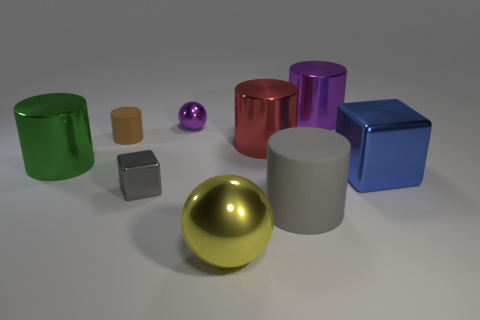There is a ball that is behind the big blue shiny object; how big is it?
Give a very brief answer. Small. How many green things are large rubber things or shiny spheres?
Provide a succinct answer. 0. Is there a yellow metallic ball that has the same size as the red metallic cylinder?
Ensure brevity in your answer.  Yes. There is a gray block that is the same size as the brown matte object; what is it made of?
Make the answer very short. Metal. Is the size of the shiny cylinder that is to the left of the brown matte thing the same as the shiny sphere in front of the green object?
Your answer should be compact. Yes. How many things are either tiny gray metal balls or objects that are to the left of the large purple shiny cylinder?
Offer a very short reply. 7. Are there any big red metal objects that have the same shape as the yellow object?
Provide a succinct answer. No. What size is the metallic cube that is right of the large cylinder in front of the tiny gray shiny thing?
Provide a succinct answer. Large. Is the large shiny sphere the same color as the tiny cylinder?
Make the answer very short. No. How many rubber objects are either tiny purple objects or big gray things?
Provide a short and direct response. 1. 